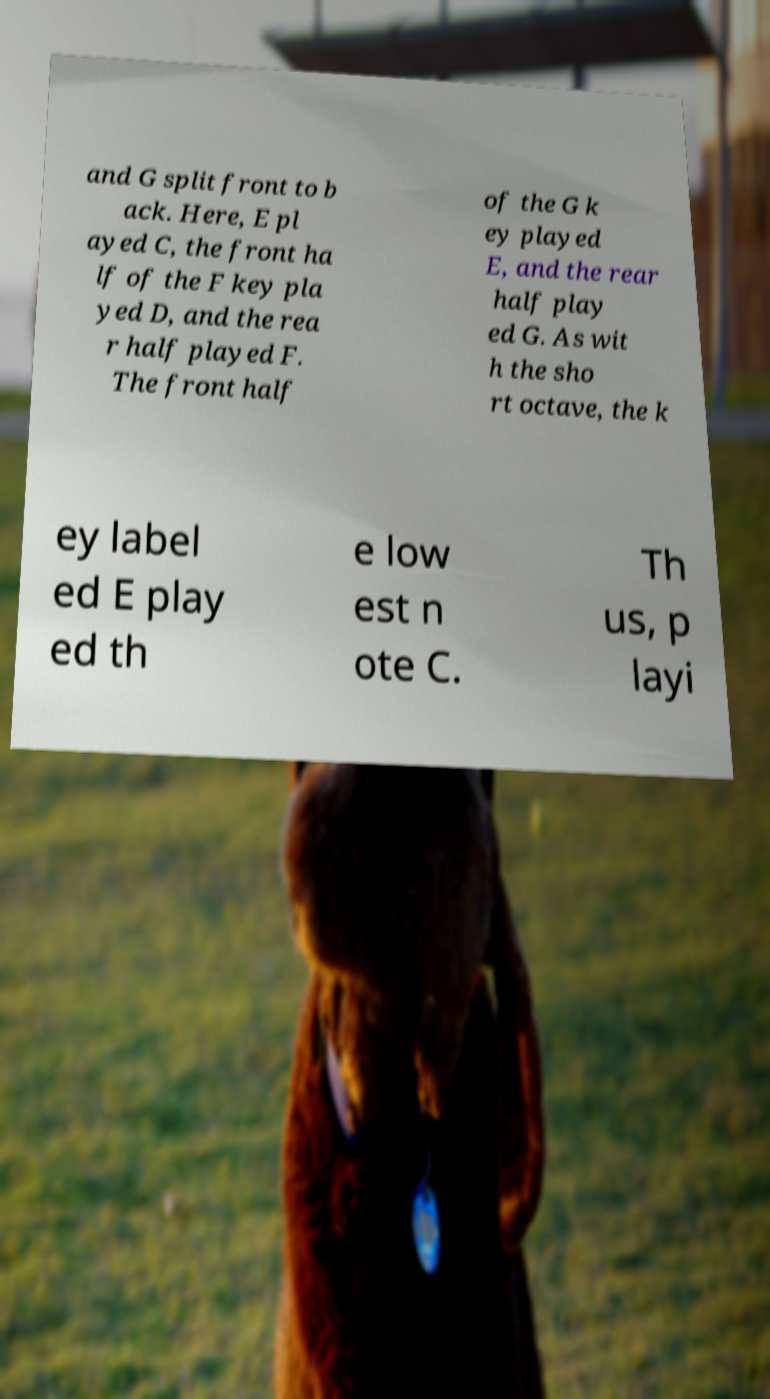What messages or text are displayed in this image? I need them in a readable, typed format. and G split front to b ack. Here, E pl ayed C, the front ha lf of the F key pla yed D, and the rea r half played F. The front half of the G k ey played E, and the rear half play ed G. As wit h the sho rt octave, the k ey label ed E play ed th e low est n ote C. Th us, p layi 